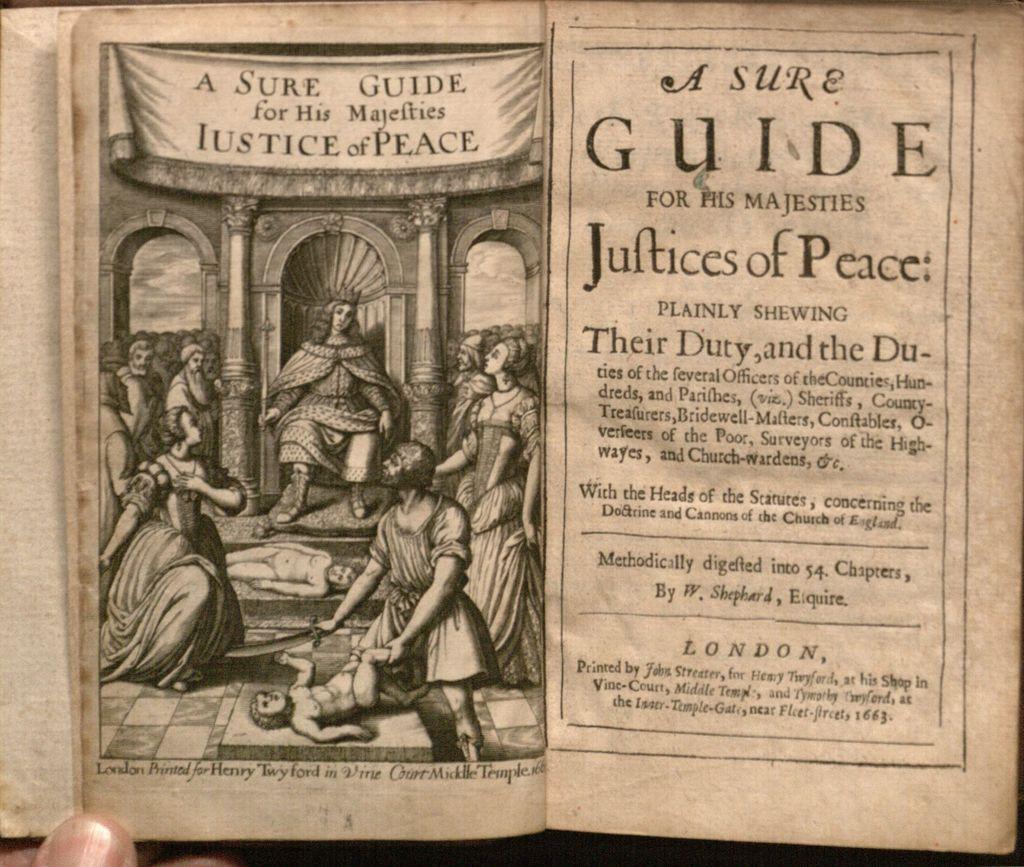How would you summarize this image in a sentence or two? In this image I can see the person holding the book. On the paper I can see the print of people and something is written on it. 